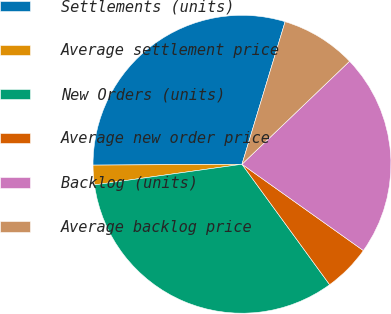<chart> <loc_0><loc_0><loc_500><loc_500><pie_chart><fcel>Settlements (units)<fcel>Average settlement price<fcel>New Orders (units)<fcel>Average new order price<fcel>Backlog (units)<fcel>Average backlog price<nl><fcel>29.77%<fcel>2.12%<fcel>32.8%<fcel>5.15%<fcel>21.99%<fcel>8.17%<nl></chart> 